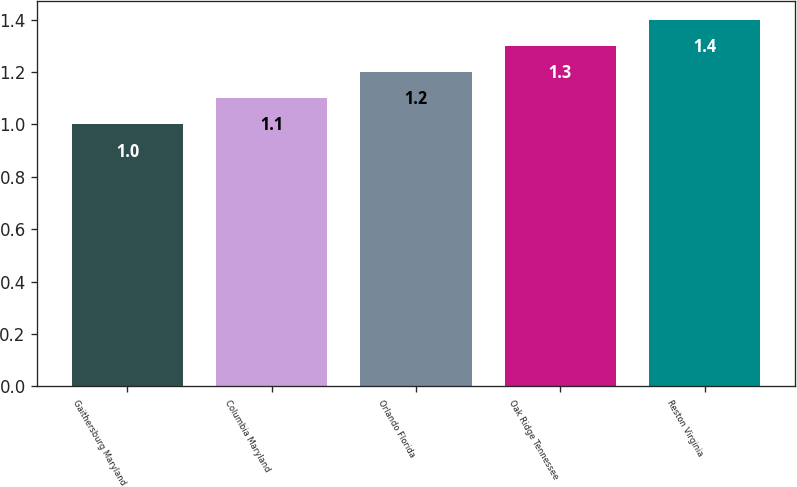<chart> <loc_0><loc_0><loc_500><loc_500><bar_chart><fcel>Gaithersburg Maryland<fcel>Columbia Maryland<fcel>Orlando Florida<fcel>Oak Ridge Tennessee<fcel>Reston Virginia<nl><fcel>1<fcel>1.1<fcel>1.2<fcel>1.3<fcel>1.4<nl></chart> 